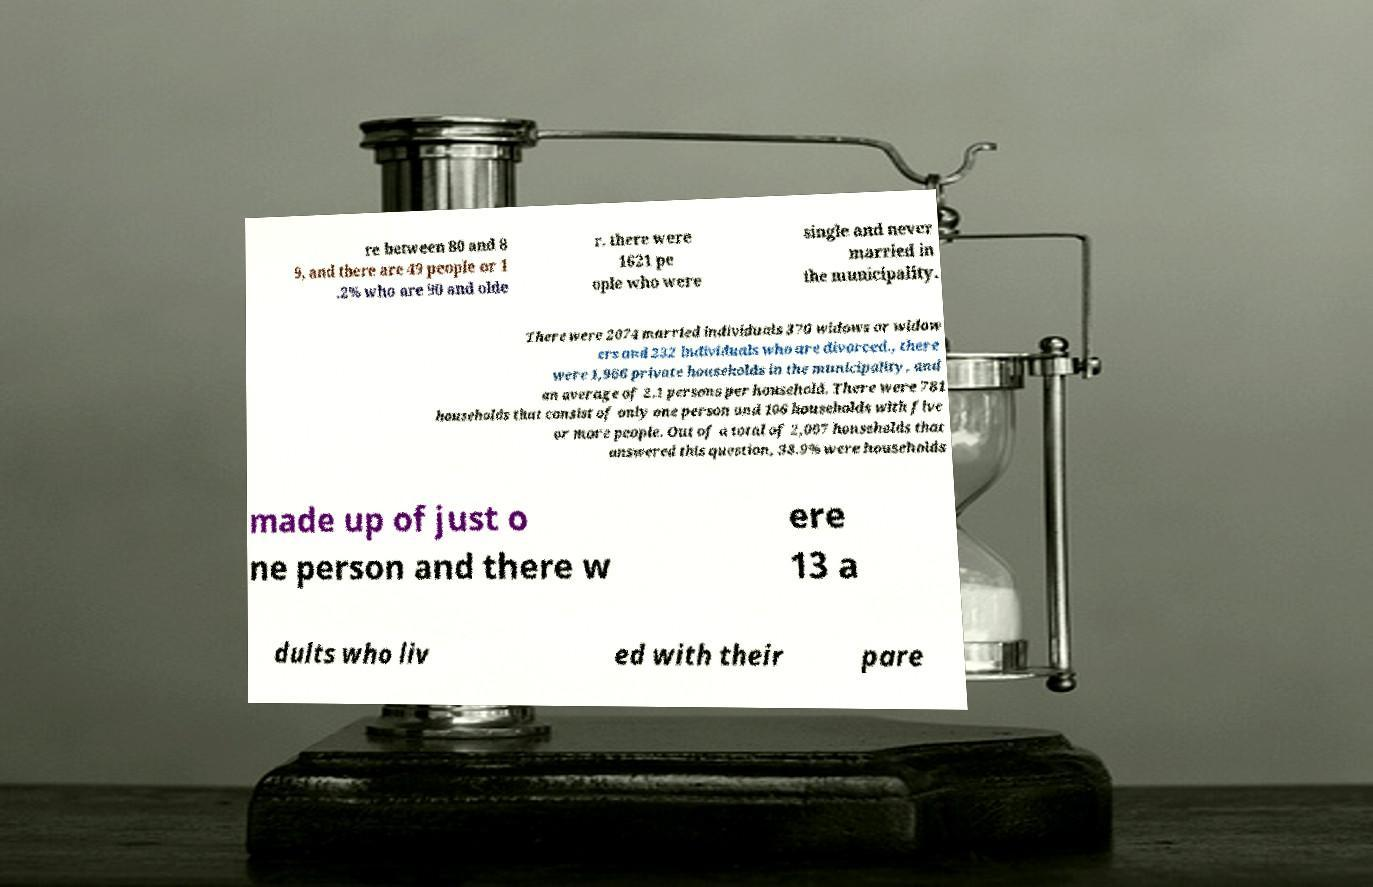Please read and relay the text visible in this image. What does it say? re between 80 and 8 9, and there are 49 people or 1 .2% who are 90 and olde r. there were 1621 pe ople who were single and never married in the municipality. There were 2074 married individuals 370 widows or widow ers and 232 individuals who are divorced., there were 1,966 private households in the municipality, and an average of 2.1 persons per household. There were 781 households that consist of only one person and 106 households with five or more people. Out of a total of 2,007 households that answered this question, 38.9% were households made up of just o ne person and there w ere 13 a dults who liv ed with their pare 